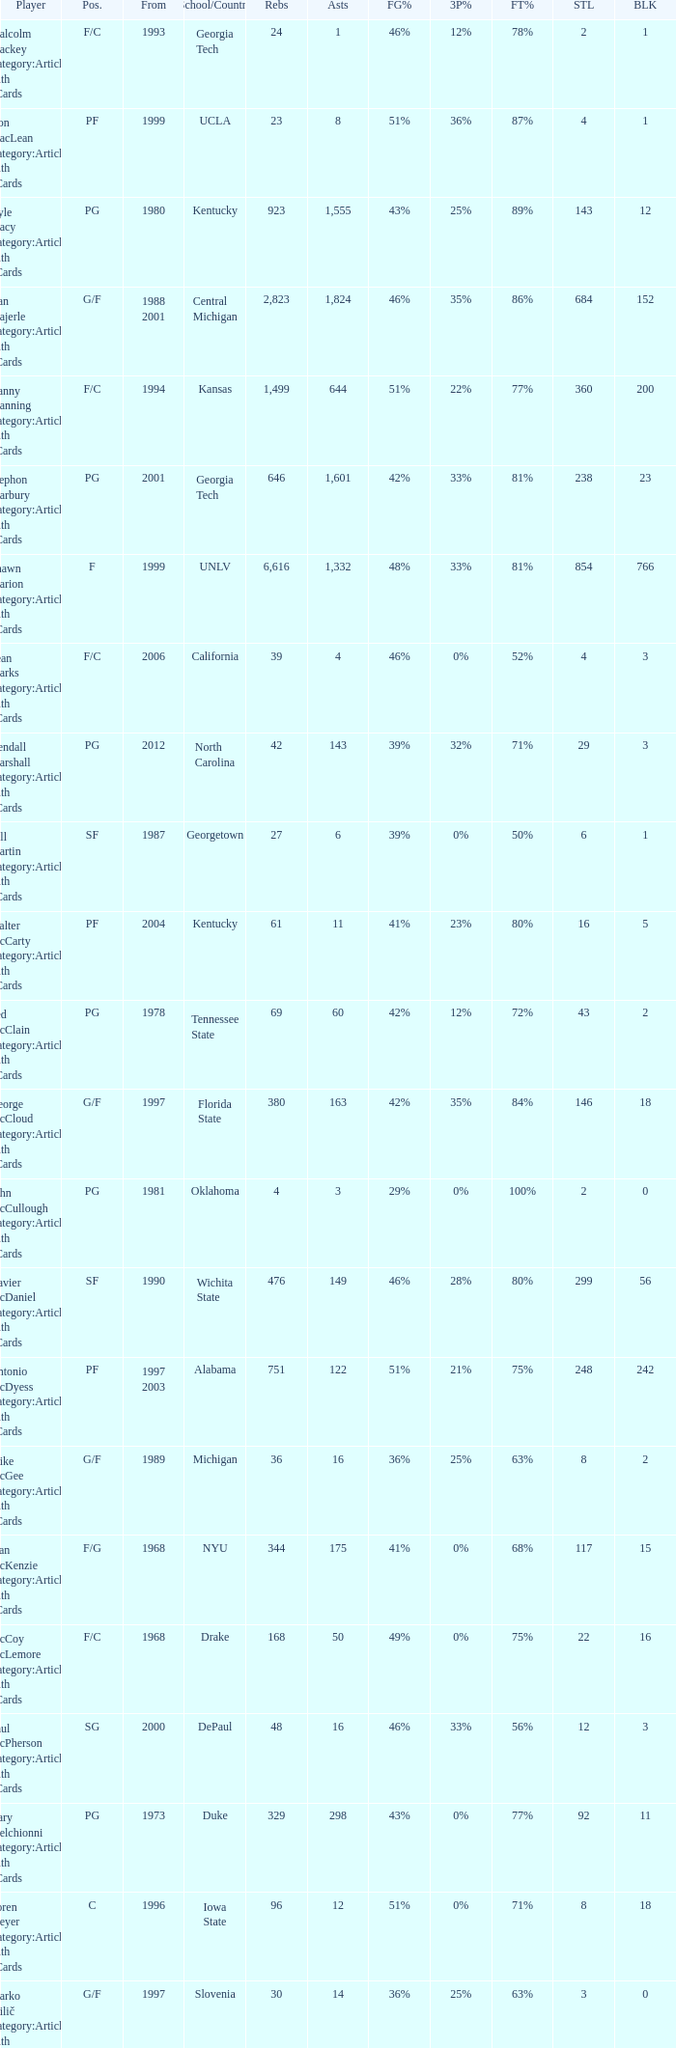Who has the high assists in 2000? 16.0. 